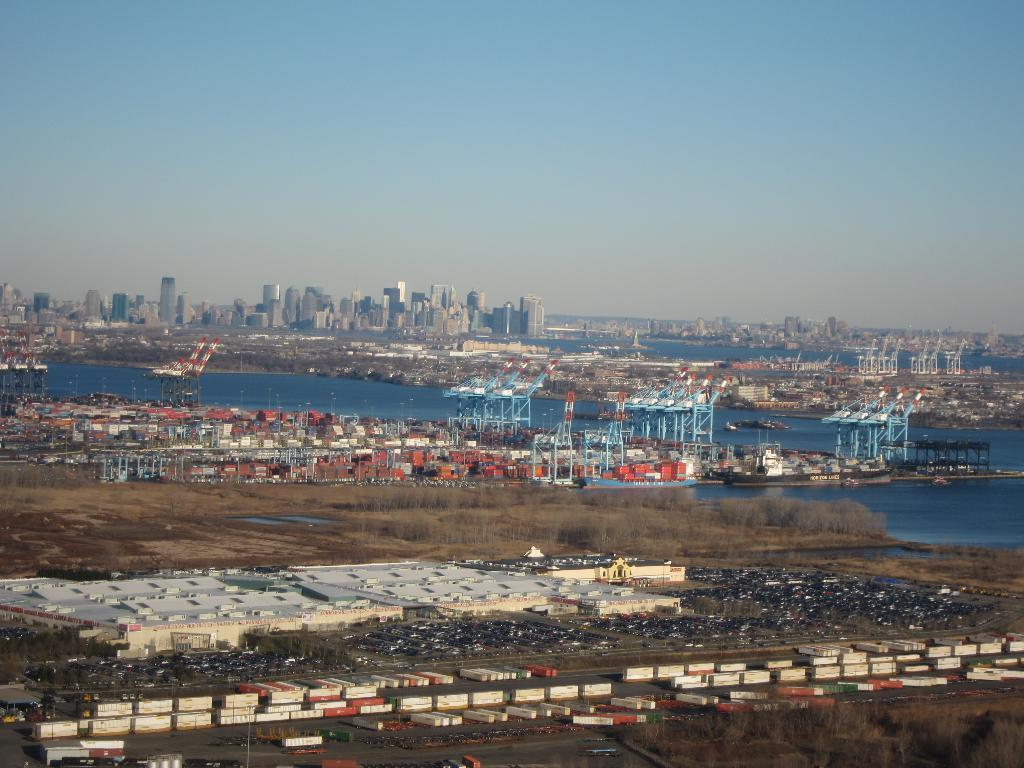What is located at the bottom of the image? There are containers and vehicles at the bottom of the image. What type of vegetation is present at the bottom of the image? Grass is present on the ground at the bottom of the image. What can be seen in the background of the image? In the background, there are containers, cranes, water, metal objects, buildings, and the sky. How many chairs are visible in the image? There are no chairs present in the image. What type of sail is attached to the cranes in the image? There are no sails present in the image; the cranes are industrial machinery. 